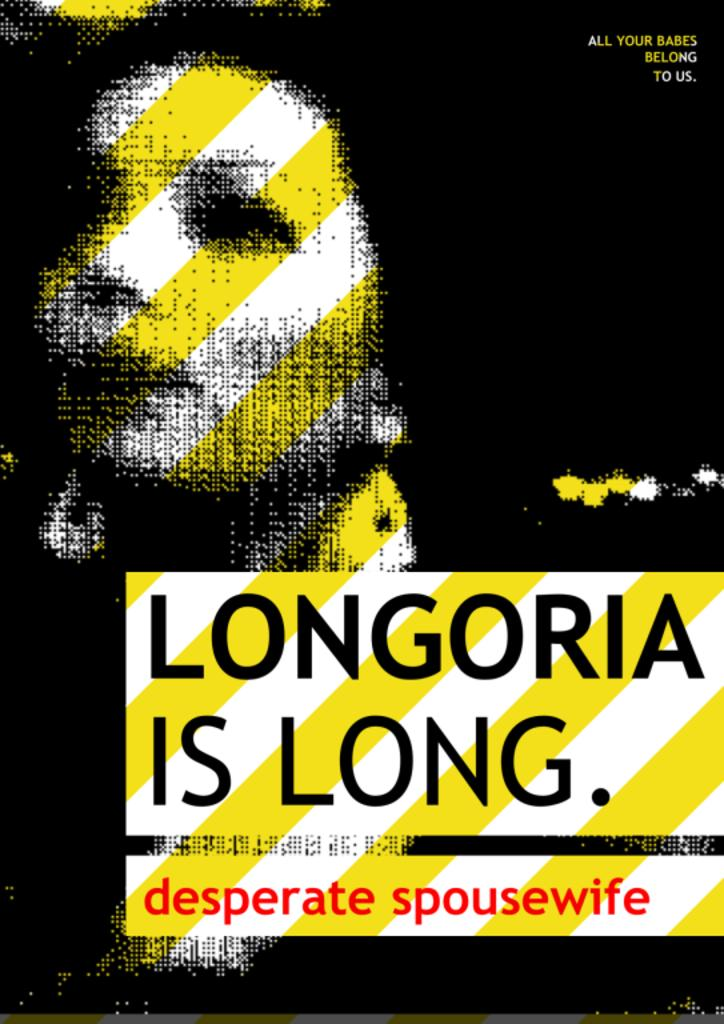<image>
Create a compact narrative representing the image presented. A satire poster about a desperate spousewife named Longoria 